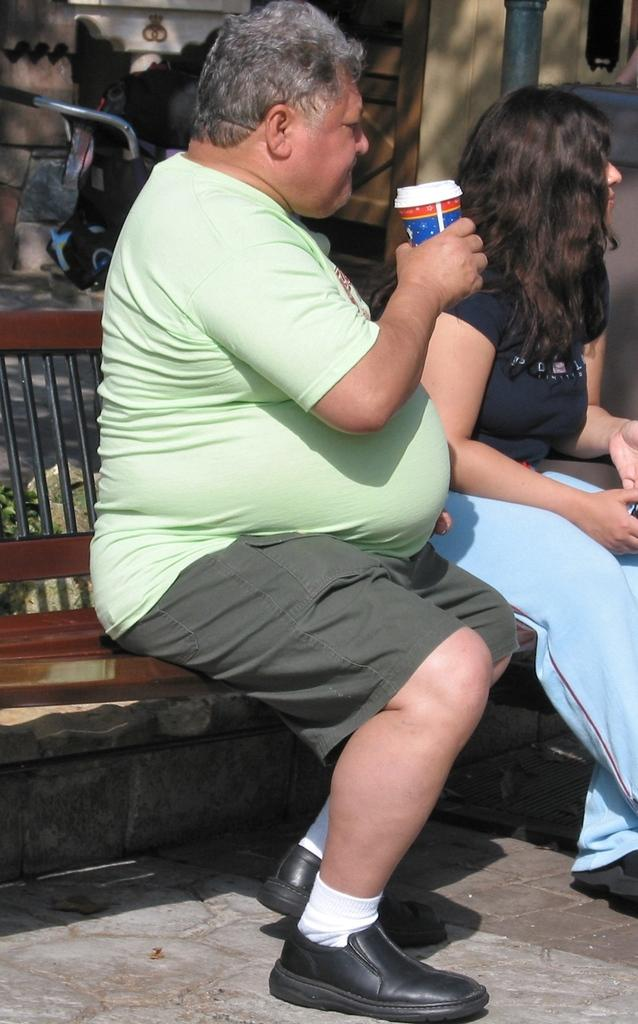How many people are in the foreground of the picture? There are two persons sitting on a wooden bench in the foreground of the picture. What are the people doing in the image? One of the persons is holding a juice glass in his hands. What type of comb is the person using to clean their throat in the image? There is no comb or throat-cleaning activity depicted in the image. 